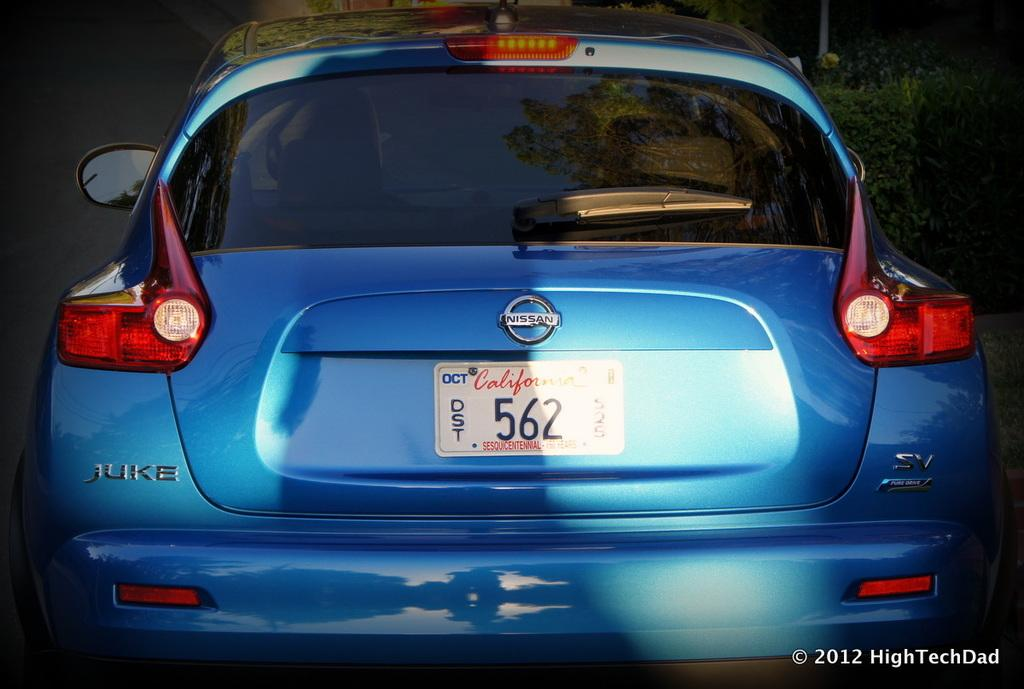<image>
Summarize the visual content of the image. The juke model of car is made by nissan. 